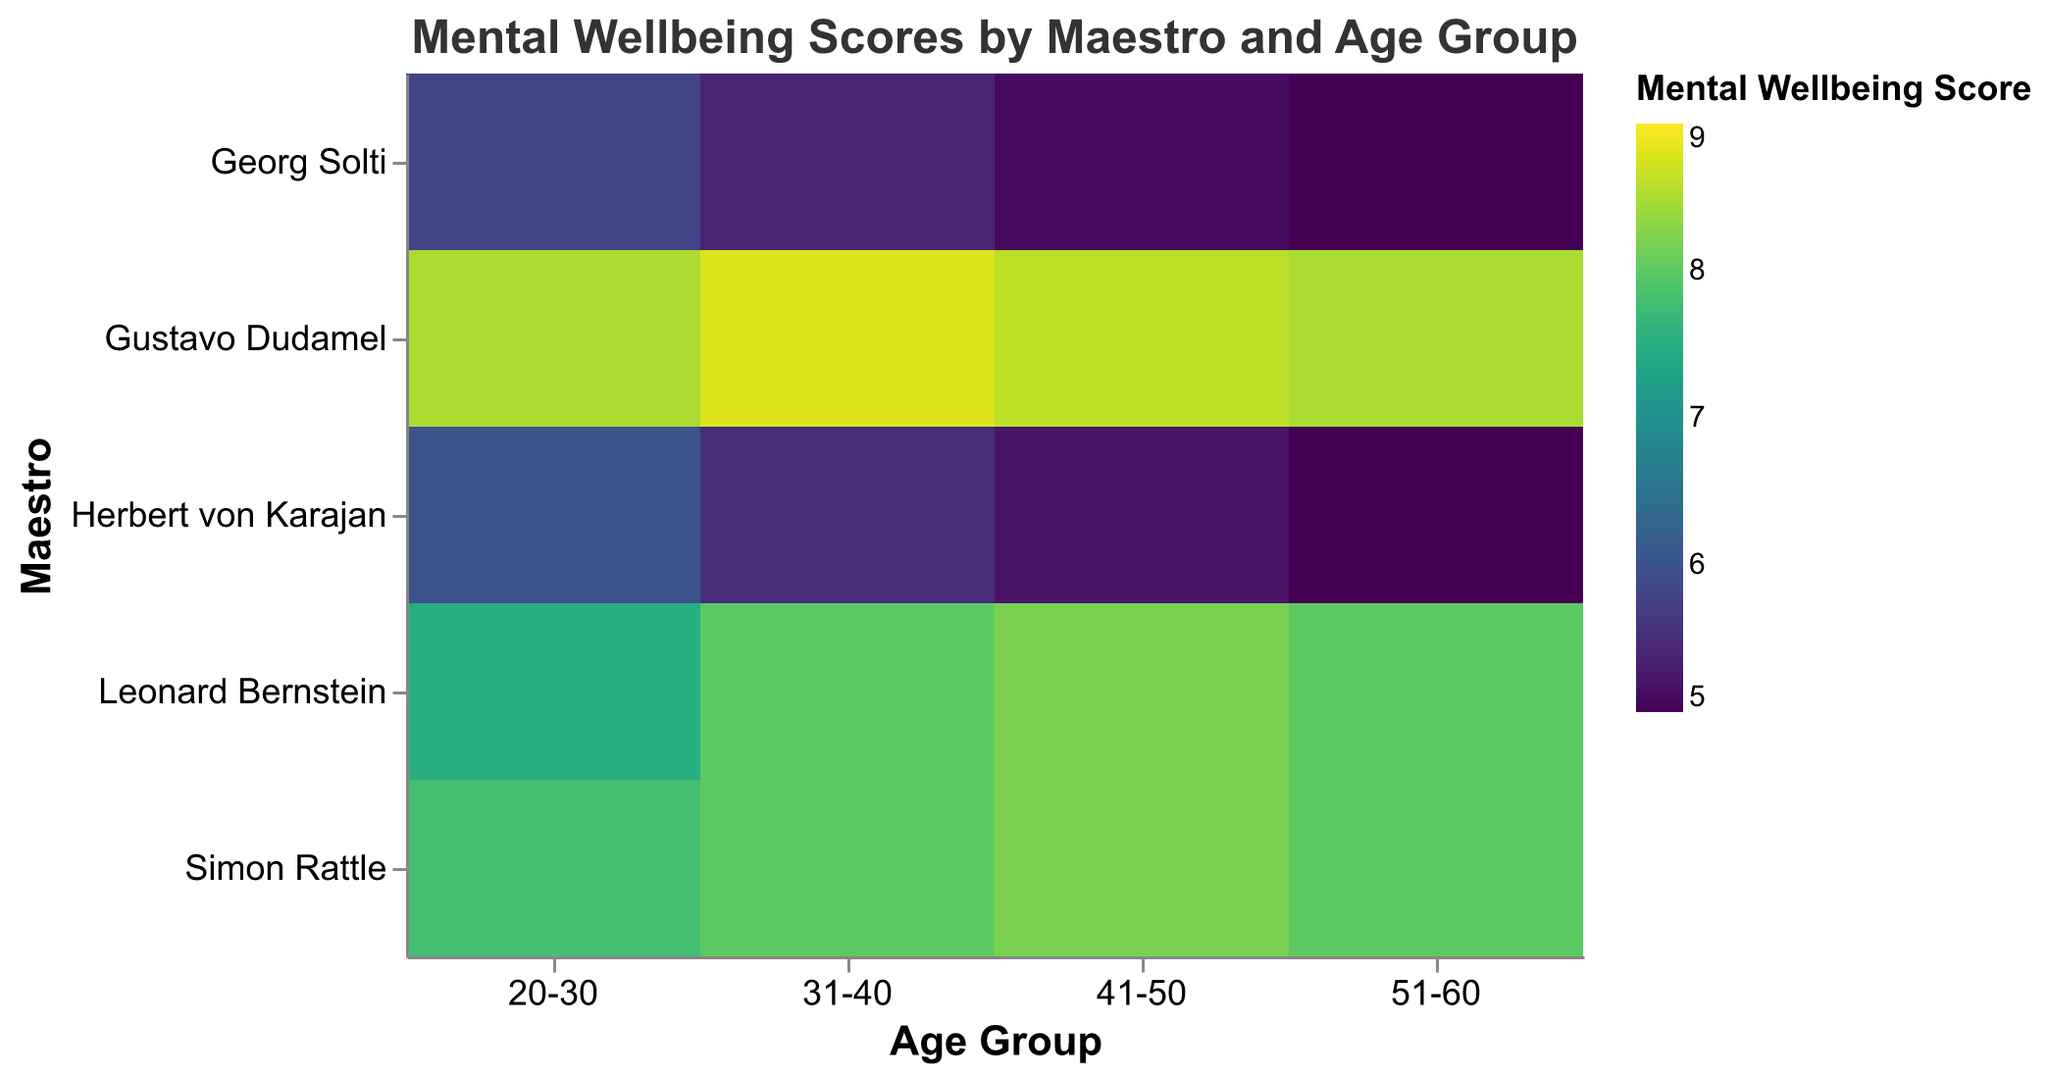What's the title of the heatmap? The title of the heatmap is displayed at the top center of the figure. The title serves to give an overview of the data being visualized.
Answer: Mental Wellbeing Scores by Maestro and Age Group Which age group has the highest average career longevity under Leonard Bernstein? To determine this, locate the rows for Leonard Bernstein and identify the column representing the highest value in Avg. Years in Career.
Answer: 51-60 Which maestro has the highest mental wellbeing score in the age group 20-30? Locate the column for age group 20-30 and identify the cell with the highest Mental Wellbeing Score across all maestros.
Answer: Gustavo Dudamel What is the difference in the average years in career between the age groups 31-40 and 41-50 under Herbert von Karajan's style? Find the values for Avg. Years in Career for Herbert von Karajan in both age groups, then subtract the 31-40 value from the 41-50 value.
Answer: 4 How does Gustavo Dudamel's teaching style impact the mental wellbeing scores of orchestra members aged 41-50 compared to Georg Solti's style? Compare the Mental Wellbeing Scores for the age group 41-50 under both maestros.
Answer: Gustavo Dudamel's score (8.6) is higher than Georg Solti's score (5.1) Which age group has the lowest mental wellbeing score under any maestro? Look through all cells to identify the minimum Mental Wellbeing Score and note the corresponding age group and maestro.
Answer: 51-60 under Herbert von Karajan What's the average Mental Wellbeing Score of all maestros for the age group 31-40? Sum the Mental Wellbeing Scores for the age group 31-40 across all maestros and divide by the number of maestros (5).
Answer: (8.0 + 5.5 + 8.8 + 5.4 + 8.0) / 5 = 35.7 / 5 = 7.14 Does a balanced teaching style (Simon Rattle) yield better mental wellbeing scores for older age groups (51-60) compared to a strict teaching style (Herbert von Karajan)? Compare the Mental Wellbeing Score for the age group 51-60 between Simon Rattle and Herbert von Karajan.
Answer: Yes, 8.0 (Simon Rattle) is better than 5.0 (Herbert von Karajan) Which maestro's strict teaching style seems to result in lower mental wellbeing scores across all age groups? Compare the Mental Wellbeing Scores for both maestros with strict styles (Herbert von Karajan and Georg Solti) across all age groups and see which has lower scores overall.
Answer: Herbert von Karajan 